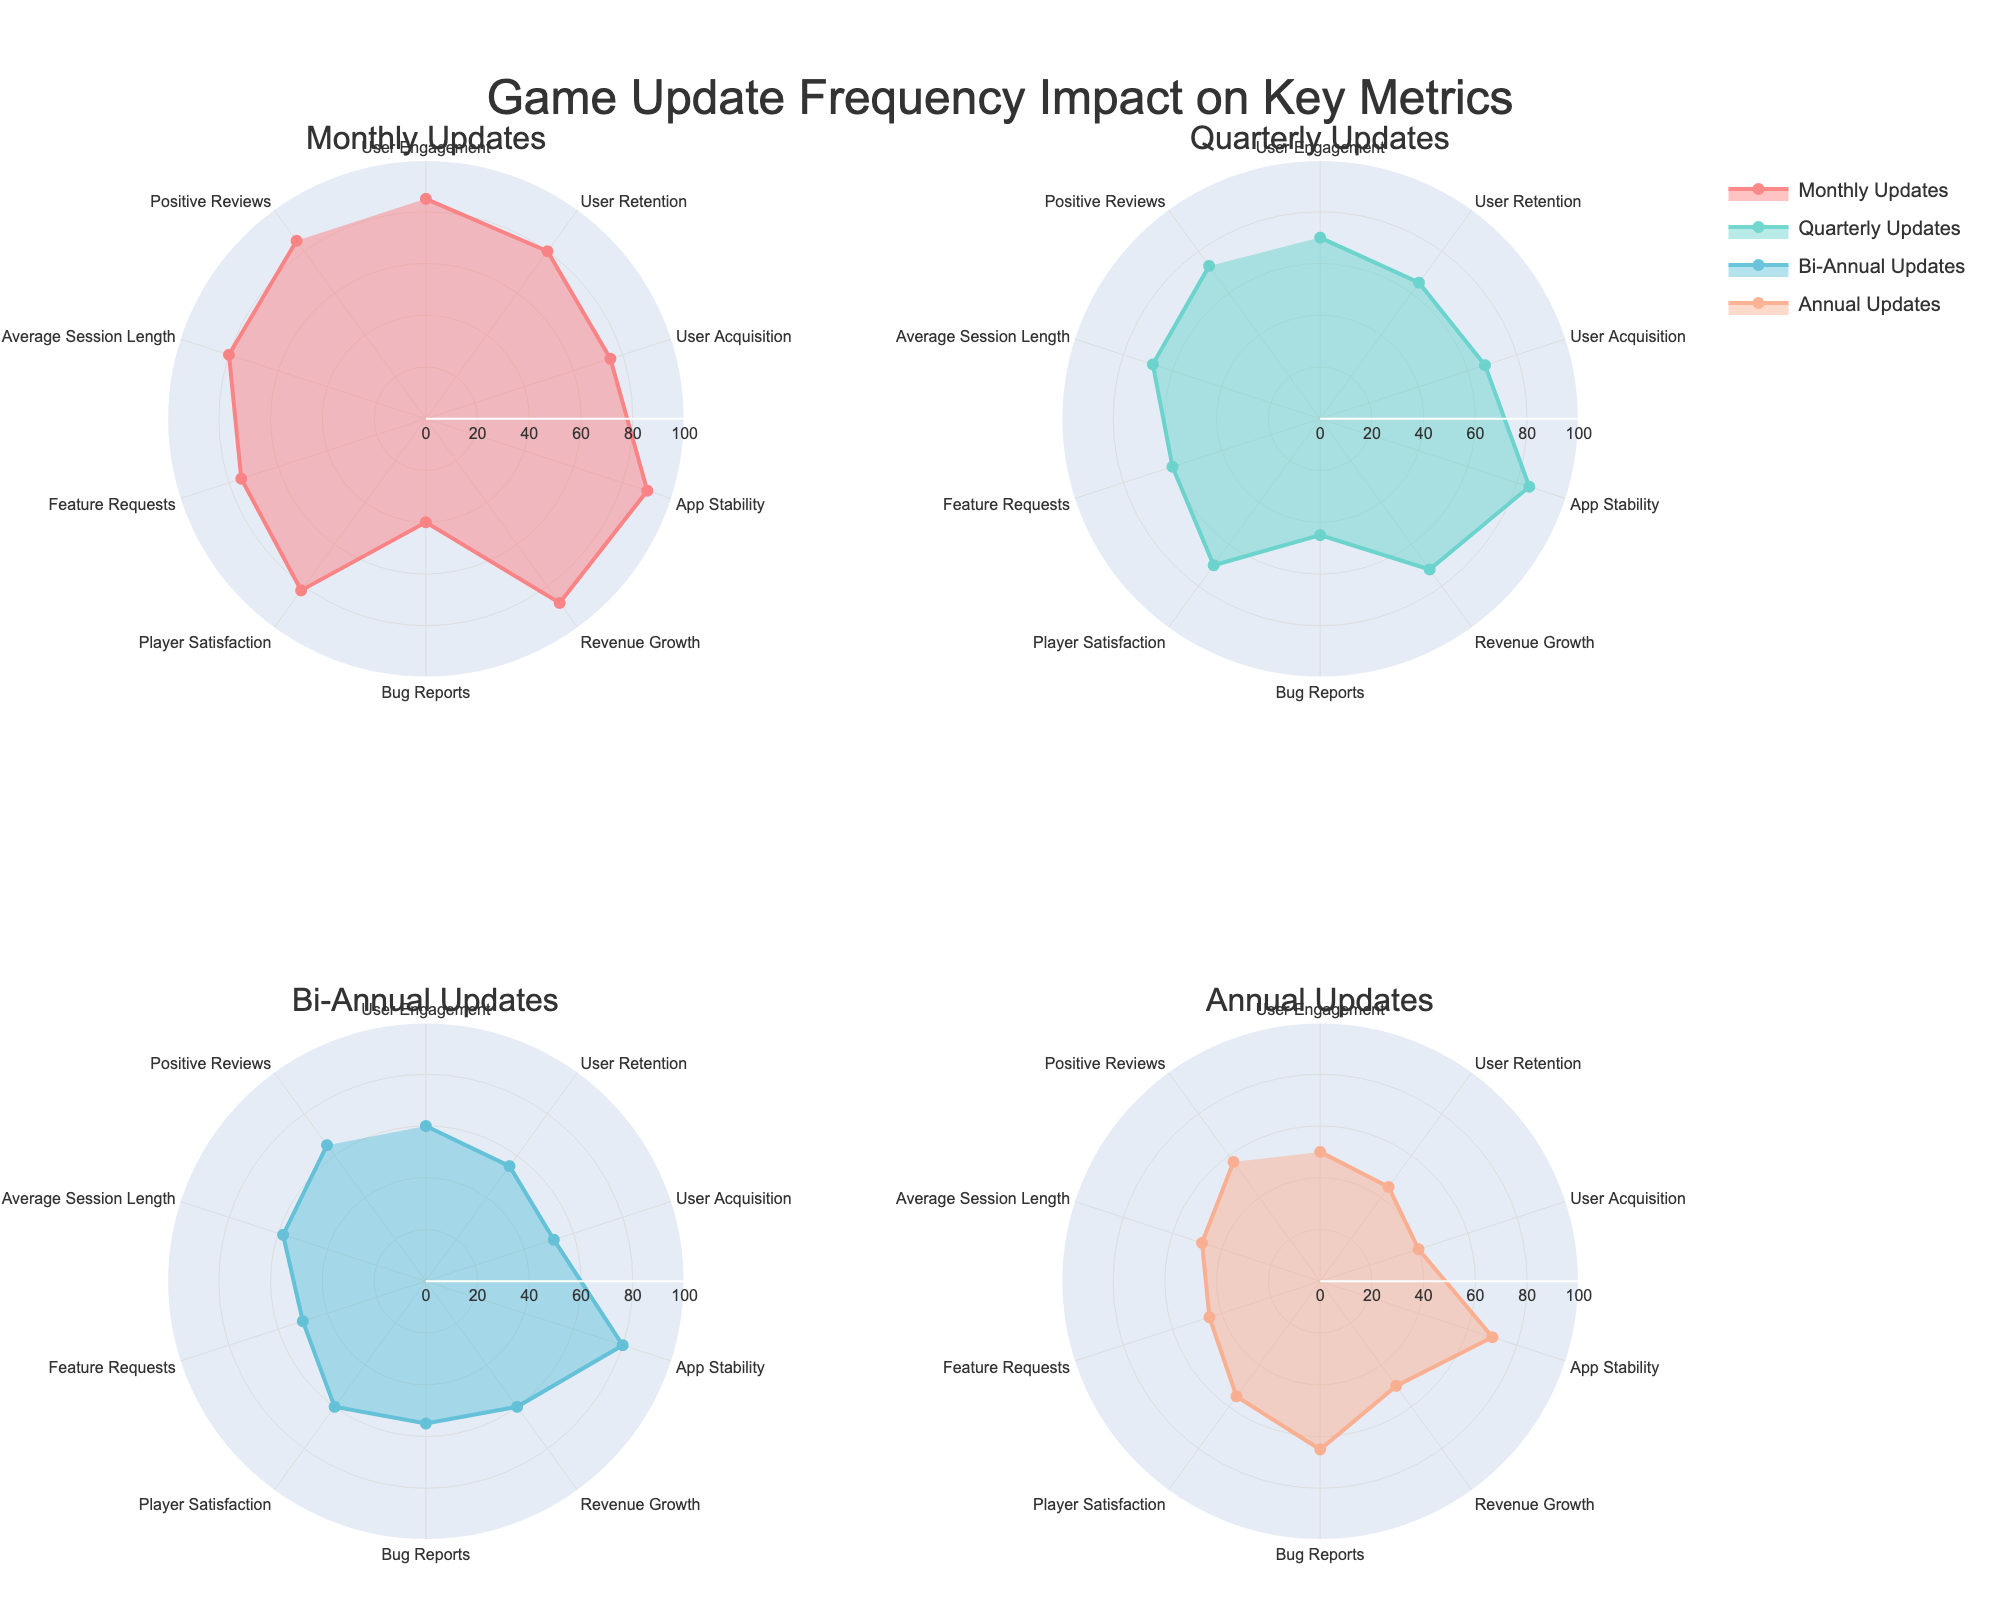what is the highest value in the Monthly Updates subplot? By observing the Monthly Updates subplot, the highest value can be found at the tip of the radial axis where the maximum extension occurs. The value is for App Stability, which reaches 90.
Answer: 90 What is the title of the figure? The title of the figure is prominently displayed at the top center of the chart. It reads "Game Update Frequency Impact on Key Metrics."
Answer: Game Update Frequency Impact on Key Metrics Which update frequency has the highest User Retention value? By comparing the User Retention values across subplots, Monthly Updates has the highest value at 80.
Answer: Monthly Updates How does Player Satisfaction vary across different update frequencies? To determine this, examine the Player Satisfaction values across all four subplots. Monthly Updates: 82, Quarterly Updates: 70, Bi-Annual Updates: 60, Annual Updates: 55.
Answer: Monthly: 82, Quarterly: 70, Bi-Annual: 60, Annual: 55 Which features have the lowest values for Monthly Updates and Annual Updates, respectively? In the Monthly Updates subplot, the lowest value is found for Bug Reports (40). In the Annual Updates subplot, the lowest value can also be found for Bug Reports (65).
Answer: Monthly: Bug Reports (40), Annual: Bug Reports (65) What is the difference in User Engagement between Monthly Updates and Annual Updates? To get the answer, subtract the Annual Updates value from the Monthly Updates value for User Engagement. Monthly Updates: 85, Annual Updates: 50. So, 85 - 50 = 35.
Answer: 35 How do bug reports compare between Bi-Annual Updates and Quarterly Updates? Bi-Annual Updates show 55 Bug Reports, while Quarterly Updates show 45 Bug Reports. Comparing these, Bi-Annual Updates have 10 more Bug Reports than Quarterly Updates.
Answer: Bi-Annual: 55, Quarterly: 45, Difference: 10 Which update frequency has the most consistent values across all features? To find the most consistent values, visually assess each subplot for the least variability in extension. Quarterly Updates appear to have the most balanced and consistent values, especially in comparison to Monthly and Bi-Annual Updates.
Answer: Quarterly Updates In which two subplots do Positive Reviews have values greater than 70? By examining the Positive Reviews values across all subplots: Monthly Updates: 85, Quarterly Updates: 73, Bi-Annual Updates: 65, Annual Updates: 57. Only Monthly Updates and Quarterly Updates have Positive Reviews above 70.
Answer: Monthly Updates, Quarterly Updates What is the average value of Revenue Growth in Quarterly and Annual Updates? To find the average, first note the values for Revenue Growth: Quarterly Updates: 72, Annual Updates: 50. Add these values together and then divide by 2: (72 + 50) / 2 = 61.
Answer: 61 